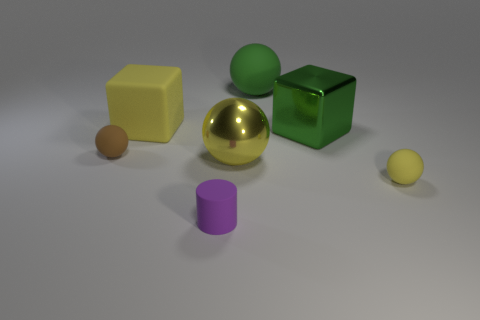Subtract all green rubber balls. How many balls are left? 3 Add 1 big green metal cubes. How many objects exist? 8 Subtract 1 blocks. How many blocks are left? 1 Subtract all brown balls. How many balls are left? 3 Subtract all brown rubber things. Subtract all small yellow things. How many objects are left? 5 Add 3 large shiny blocks. How many large shiny blocks are left? 4 Add 4 tiny purple things. How many tiny purple things exist? 5 Subtract 1 purple cylinders. How many objects are left? 6 Subtract all balls. How many objects are left? 3 Subtract all blue cylinders. Subtract all gray spheres. How many cylinders are left? 1 